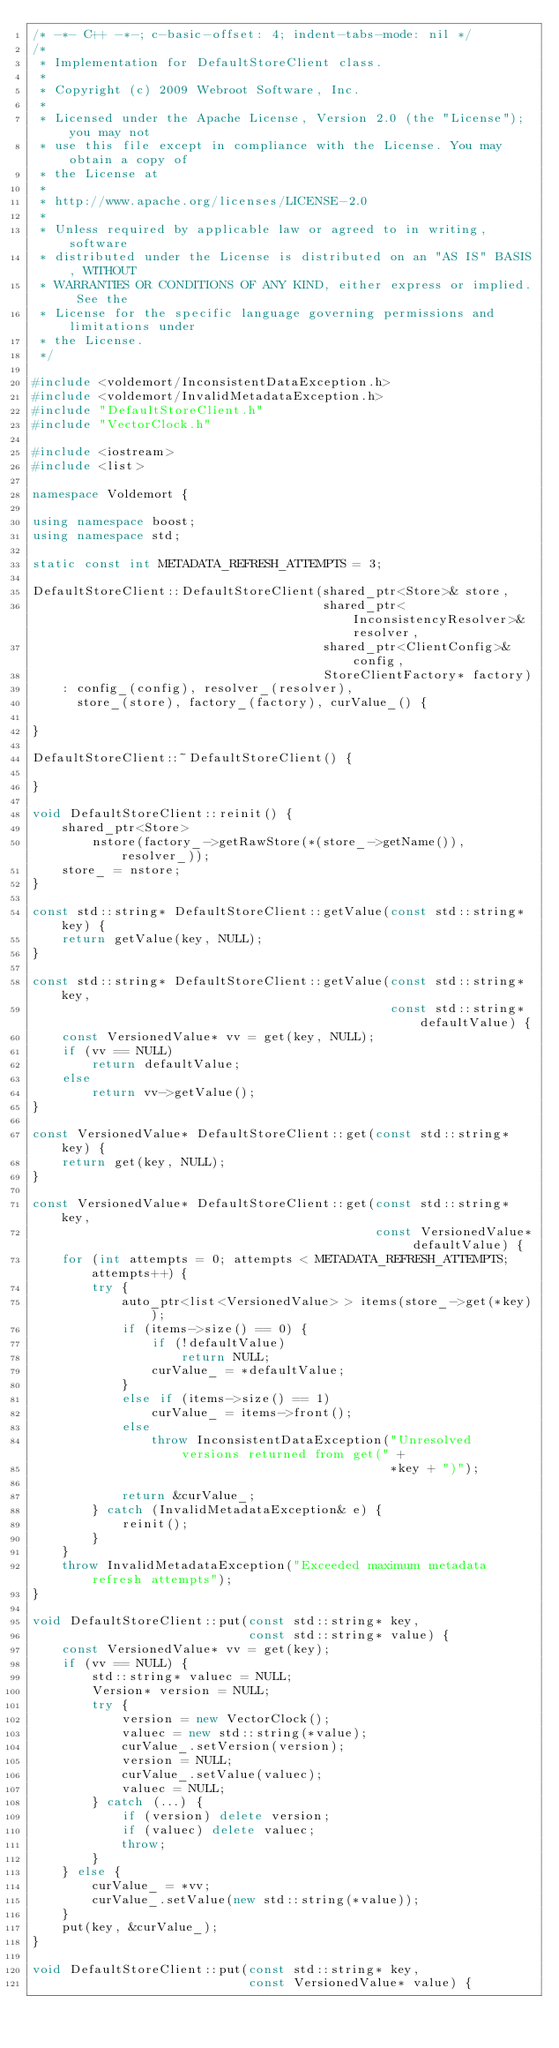Convert code to text. <code><loc_0><loc_0><loc_500><loc_500><_C++_>/* -*- C++ -*-; c-basic-offset: 4; indent-tabs-mode: nil */
/*
 * Implementation for DefaultStoreClient class.
 * 
 * Copyright (c) 2009 Webroot Software, Inc.
 *
 * Licensed under the Apache License, Version 2.0 (the "License"); you may not
 * use this file except in compliance with the License. You may obtain a copy of
 * the License at
 * 
 * http://www.apache.org/licenses/LICENSE-2.0
 * 
 * Unless required by applicable law or agreed to in writing, software
 * distributed under the License is distributed on an "AS IS" BASIS, WITHOUT
 * WARRANTIES OR CONDITIONS OF ANY KIND, either express or implied. See the
 * License for the specific language governing permissions and limitations under
 * the License.
 */

#include <voldemort/InconsistentDataException.h>
#include <voldemort/InvalidMetadataException.h>
#include "DefaultStoreClient.h"
#include "VectorClock.h"

#include <iostream>
#include <list>

namespace Voldemort {

using namespace boost;
using namespace std;

static const int METADATA_REFRESH_ATTEMPTS = 3;

DefaultStoreClient::DefaultStoreClient(shared_ptr<Store>& store,
                                       shared_ptr<InconsistencyResolver>& resolver,
                                       shared_ptr<ClientConfig>& config,
                                       StoreClientFactory* factory) 
    : config_(config), resolver_(resolver),
      store_(store), factory_(factory), curValue_() {

}

DefaultStoreClient::~DefaultStoreClient() {

}

void DefaultStoreClient::reinit() {
    shared_ptr<Store> 
        nstore(factory_->getRawStore(*(store_->getName()), resolver_));
    store_ = nstore;
}

const std::string* DefaultStoreClient::getValue(const std::string* key) {
    return getValue(key, NULL);
}

const std::string* DefaultStoreClient::getValue(const std::string* key,
                                                const std::string* defaultValue) {
    const VersionedValue* vv = get(key, NULL);
    if (vv == NULL)
        return defaultValue;
    else
        return vv->getValue();
}

const VersionedValue* DefaultStoreClient::get(const std::string* key) {
    return get(key, NULL);
}

const VersionedValue* DefaultStoreClient::get(const std::string* key,
                                              const VersionedValue* defaultValue) {
    for (int attempts = 0; attempts < METADATA_REFRESH_ATTEMPTS; attempts++) {
        try {
            auto_ptr<list<VersionedValue> > items(store_->get(*key));
            if (items->size() == 0) {
                if (!defaultValue)
                    return NULL;
                curValue_ = *defaultValue;
            }
            else if (items->size() == 1)
                curValue_ = items->front();
            else
                throw InconsistentDataException("Unresolved versions returned from get(" +
                                                *key + ")");

            return &curValue_;
        } catch (InvalidMetadataException& e) {
            reinit();
        }
    }
    throw InvalidMetadataException("Exceeded maximum metadata refresh attempts");
}

void DefaultStoreClient::put(const std::string* key, 
                             const std::string* value) {
    const VersionedValue* vv = get(key);
    if (vv == NULL) {
        std::string* valuec = NULL;
        Version* version = NULL;
        try {
            version = new VectorClock();
            valuec = new std::string(*value);
            curValue_.setVersion(version);
            version = NULL;
            curValue_.setValue(valuec);
            valuec = NULL;
        } catch (...) {
            if (version) delete version;
            if (valuec) delete valuec;
            throw;
        }
    } else {
        curValue_ = *vv;
        curValue_.setValue(new std::string(*value));
    }
    put(key, &curValue_);
}

void DefaultStoreClient::put(const std::string* key, 
                             const VersionedValue* value) {</code> 